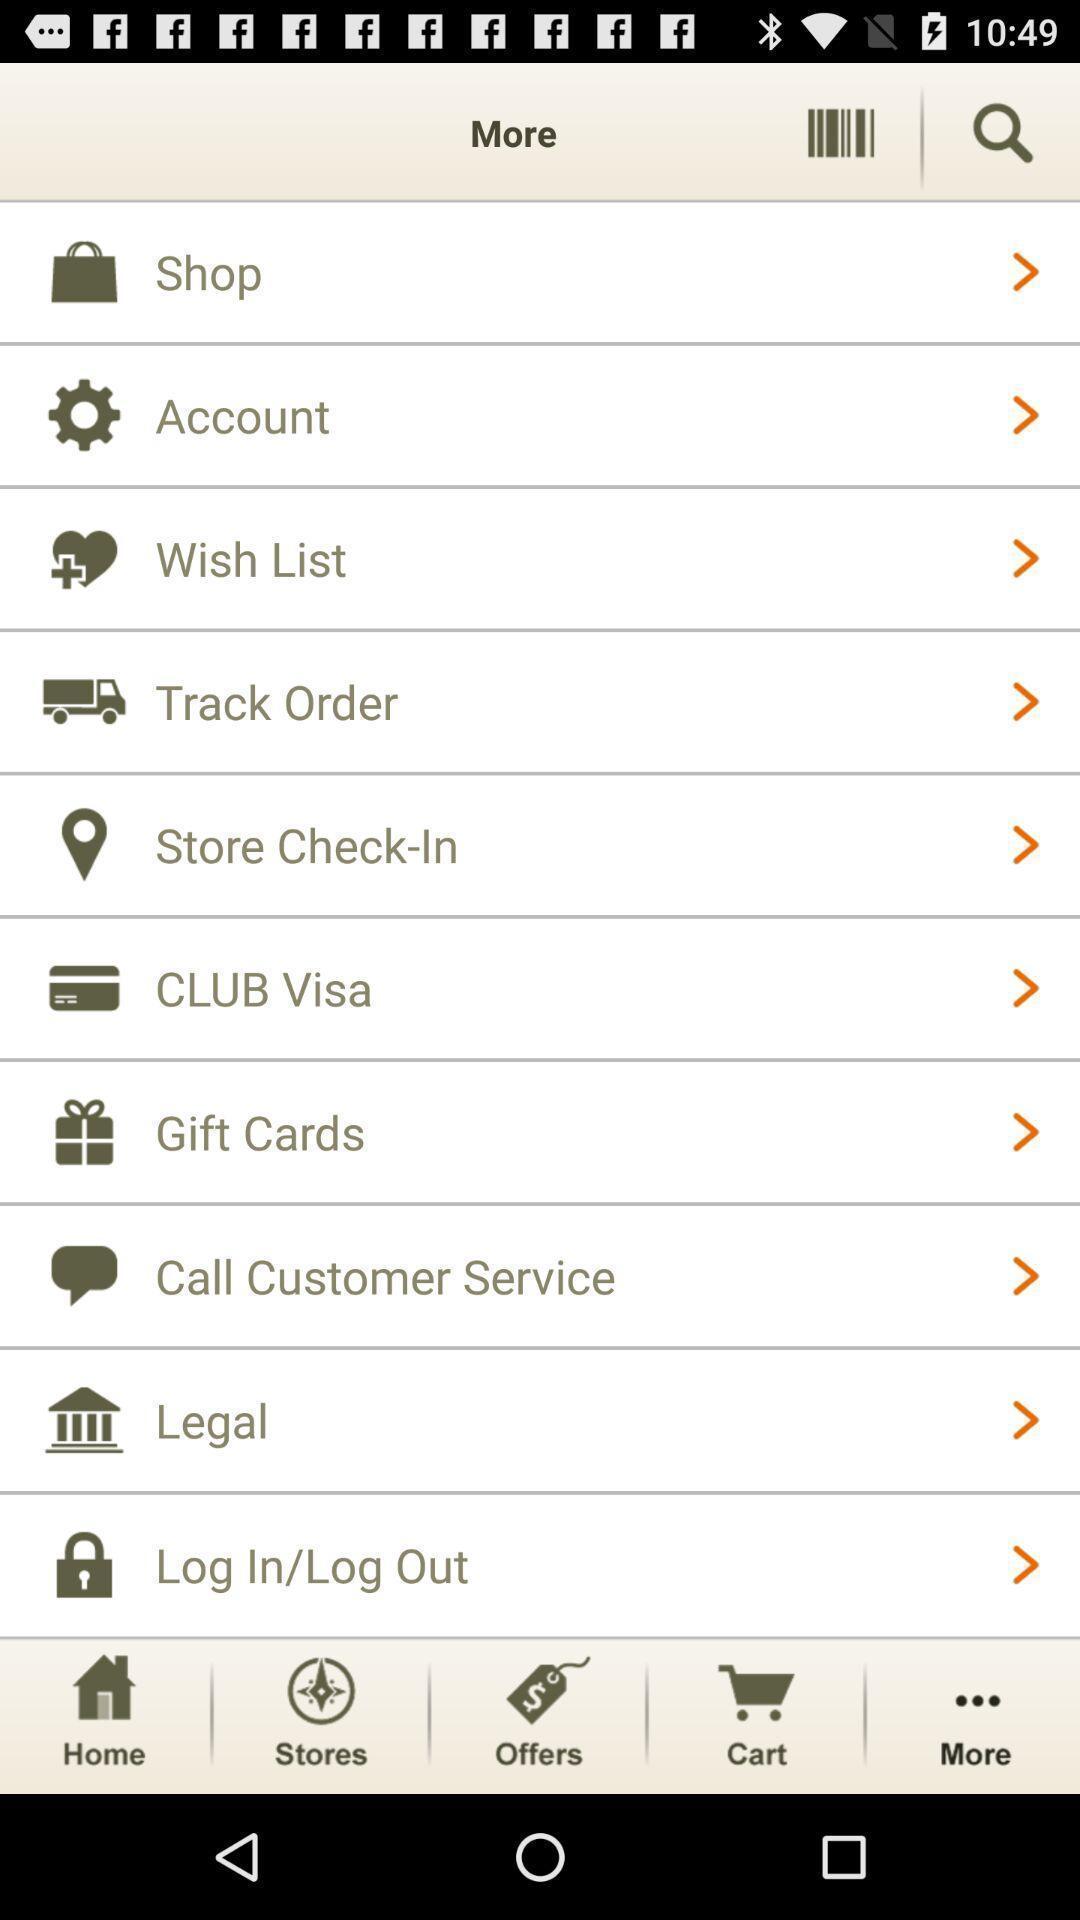Describe the content in this image. Page displaying with list of settings in a shopping application. 